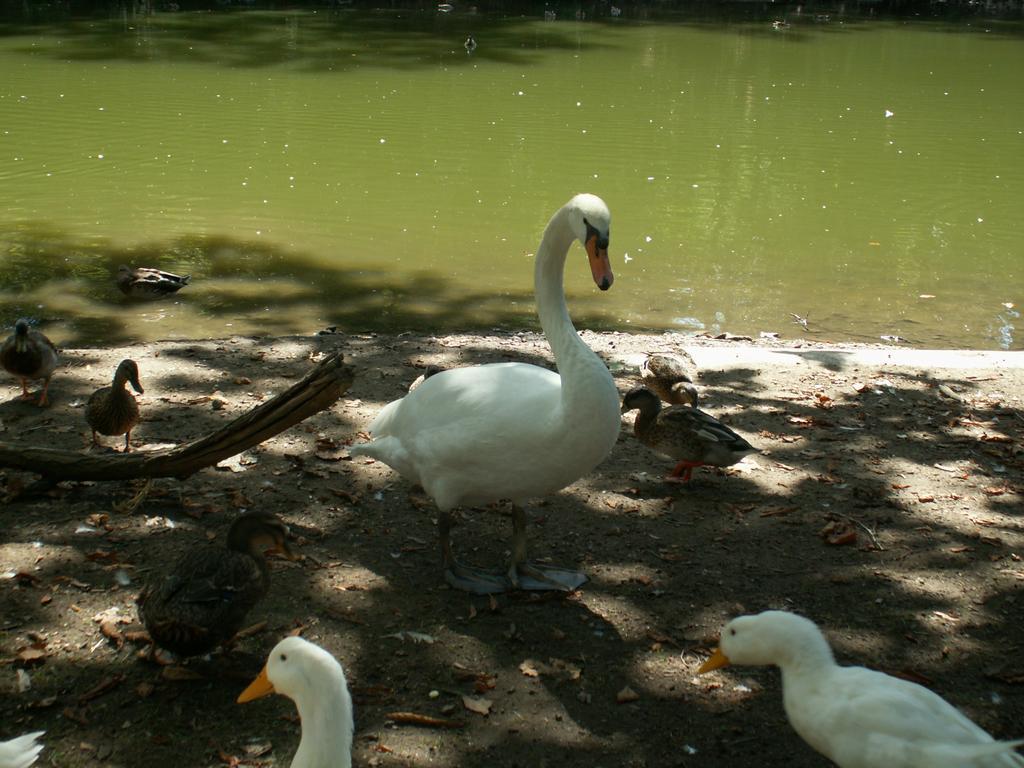In one or two sentences, can you explain what this image depicts? In this images we can see water, ducks and ducklings on the ground. 